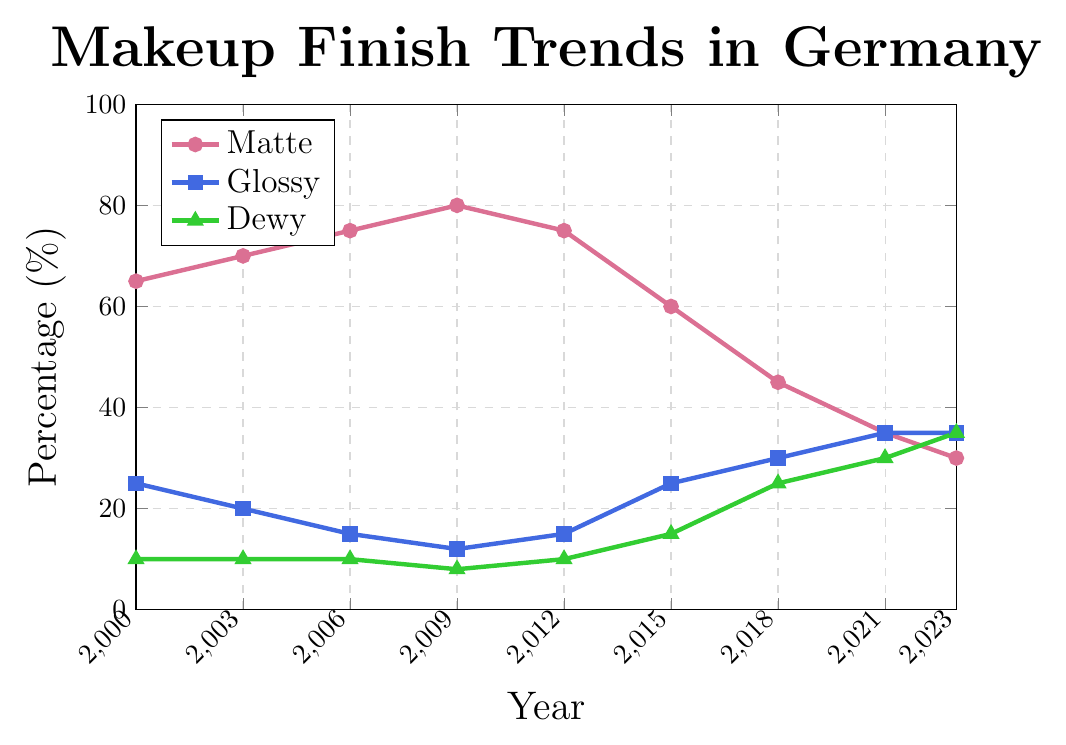When did the preference for matte finishes peak? By observing the line representing matte finishes, we can see the peak is at the highest point on the graph. This occurs at the year 2009, where the preference percentage reaches 80%.
Answer: 2009 Which year saw glossy finishes equaling dewy finishes in popularity? To determine this, we need to look for the intersection or equal height of the lines representing glossy and dewy finishes. When both lines are at 35%, it happens in 2023.
Answer: 2023 How did the preference for dewy finishes change from 2000 to 2023? The dewy line starts at 10% in 2000 and steadily increases to end at 35% in 2023.
Answer: Increased by 25 percentage points What is the average preference for matte finishes between 2000 and 2023? Adding all the values for matte finishes and then dividing by the number of years (9 years) gives: (65+70+75+80+75+60+45+35+30)/9 = 535/9 = 59.44%.
Answer: 59.44% Which finish had the highest growth rate from 2015 to 2023? Comparing the changes, matte decreased from 60% to 30% (-30 points), glossy increased from 25% to 35% (+10 points), and dewy increased from 15% to 35% (+20 points). Dewy finish shows the highest growth.
Answer: Dewy What is the combined popularity of glossy and dewy finishes in 2021? Sum the percentages of glossy (35%) and dewy (30%) finishes in 2021. 35% + 30% = 65%.
Answer: 65% In which year did matte finishes first start to decline? Observing when the line representing matte finishes first starts to drop after increasing, the year is 2009 to 2012 (from 80% to 75%).
Answer: 2012 Which finish was the most popular in 2018? By observing the height of the lines in 2018, matte has 45%, glossy has 30%, dewy has 25%. Matte is the most popular.
Answer: Matte Between 2000 and 2015, which finish experienced the largest net decrease in preference? By calculating the changes: Matte: (60 - 65) = -5 points, Glossy: (25 - 25) = 0 points, Dewy: (15 - 10) = 5 points; matte experienced the largest net decrease.
Answer: Matte 